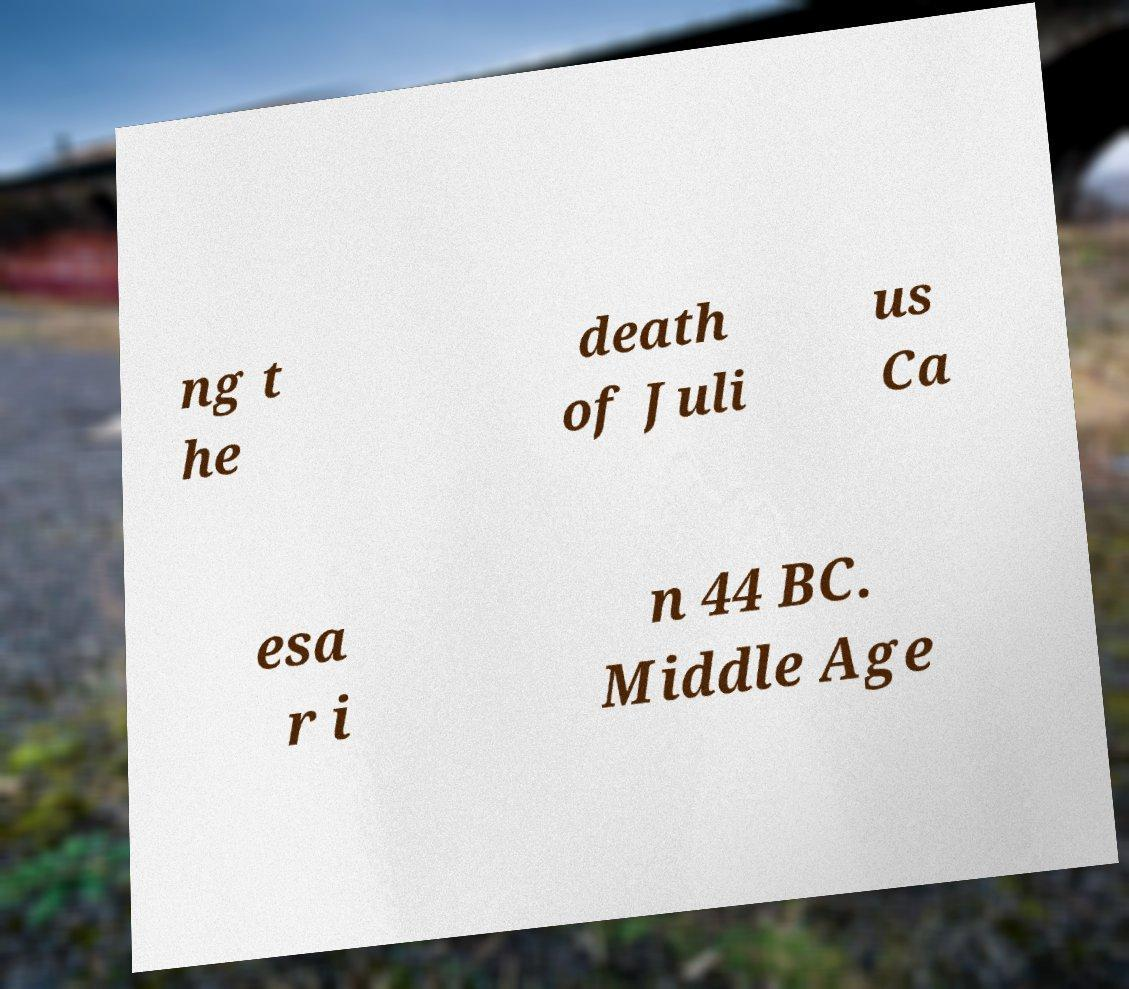Can you read and provide the text displayed in the image?This photo seems to have some interesting text. Can you extract and type it out for me? ng t he death of Juli us Ca esa r i n 44 BC. Middle Age 